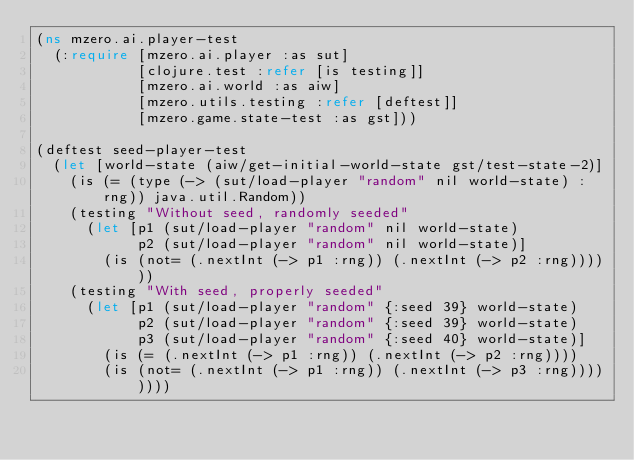<code> <loc_0><loc_0><loc_500><loc_500><_Clojure_>(ns mzero.ai.player-test
  (:require [mzero.ai.player :as sut]
            [clojure.test :refer [is testing]]
            [mzero.ai.world :as aiw]
            [mzero.utils.testing :refer [deftest]]
            [mzero.game.state-test :as gst]))

(deftest seed-player-test
  (let [world-state (aiw/get-initial-world-state gst/test-state-2)]
    (is (= (type (-> (sut/load-player "random" nil world-state) :rng)) java.util.Random))
    (testing "Without seed, randomly seeded"
      (let [p1 (sut/load-player "random" nil world-state)
            p2 (sut/load-player "random" nil world-state)]
        (is (not= (.nextInt (-> p1 :rng)) (.nextInt (-> p2 :rng))))))
    (testing "With seed, properly seeded"
      (let [p1 (sut/load-player "random" {:seed 39} world-state)
            p2 (sut/load-player "random" {:seed 39} world-state)
            p3 (sut/load-player "random" {:seed 40} world-state)]
        (is (= (.nextInt (-> p1 :rng)) (.nextInt (-> p2 :rng))))
        (is (not= (.nextInt (-> p1 :rng)) (.nextInt (-> p3 :rng))))))))
</code> 